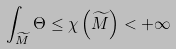<formula> <loc_0><loc_0><loc_500><loc_500>\int _ { \widetilde { M } } \Theta \leq \chi \left ( \widetilde { M } \right ) < + \infty</formula> 